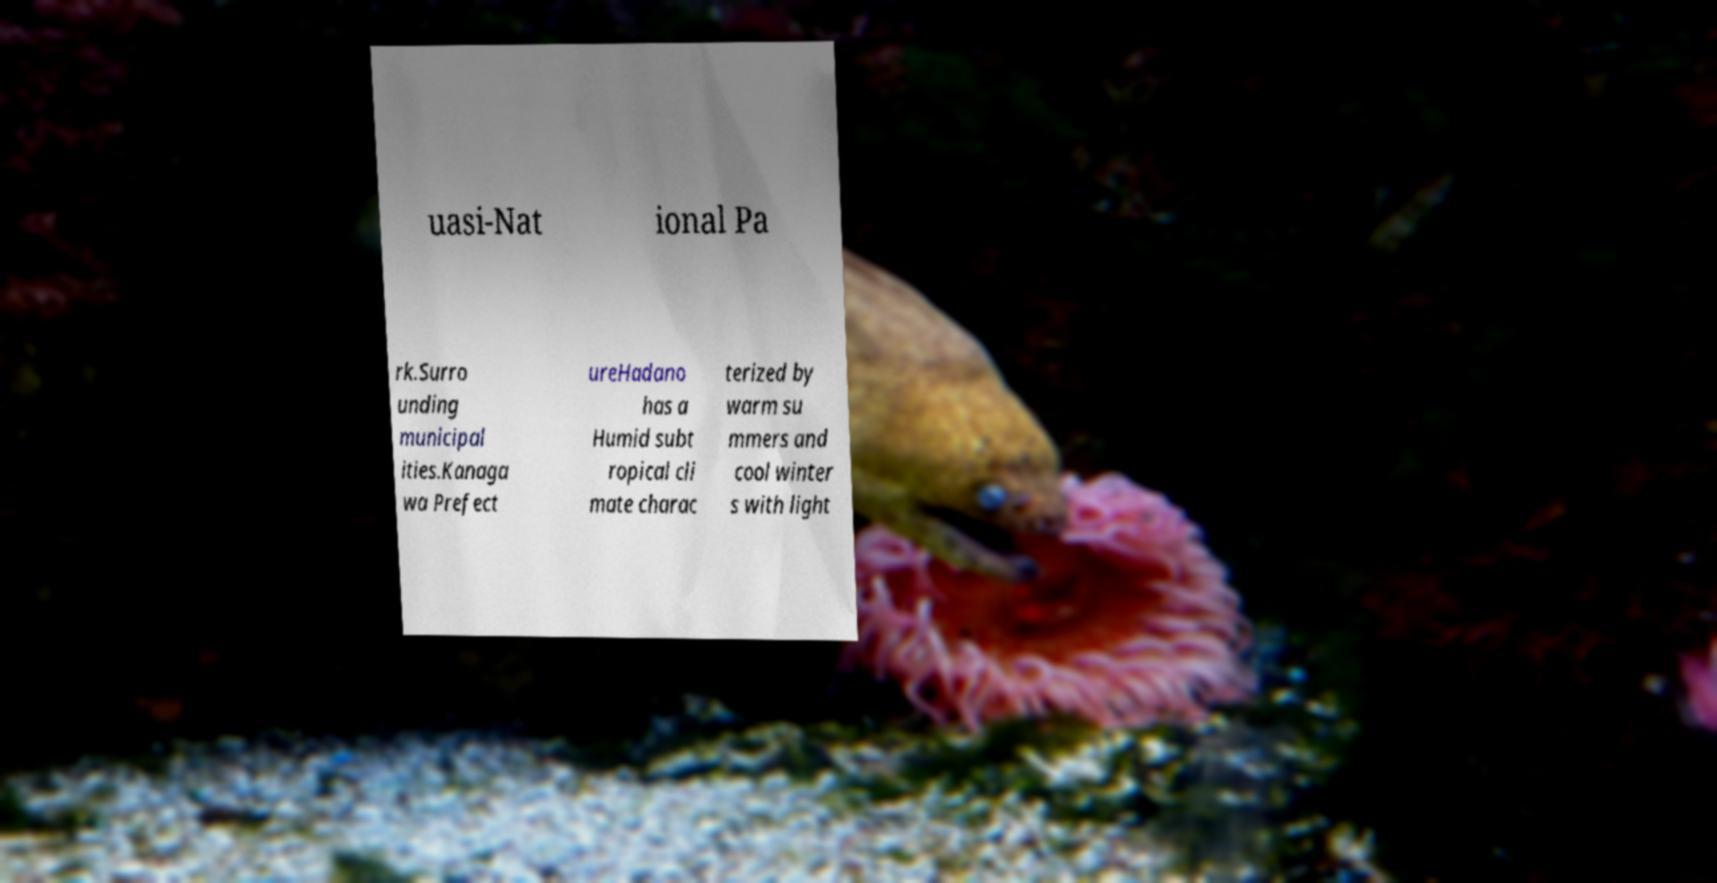Please identify and transcribe the text found in this image. uasi-Nat ional Pa rk.Surro unding municipal ities.Kanaga wa Prefect ureHadano has a Humid subt ropical cli mate charac terized by warm su mmers and cool winter s with light 